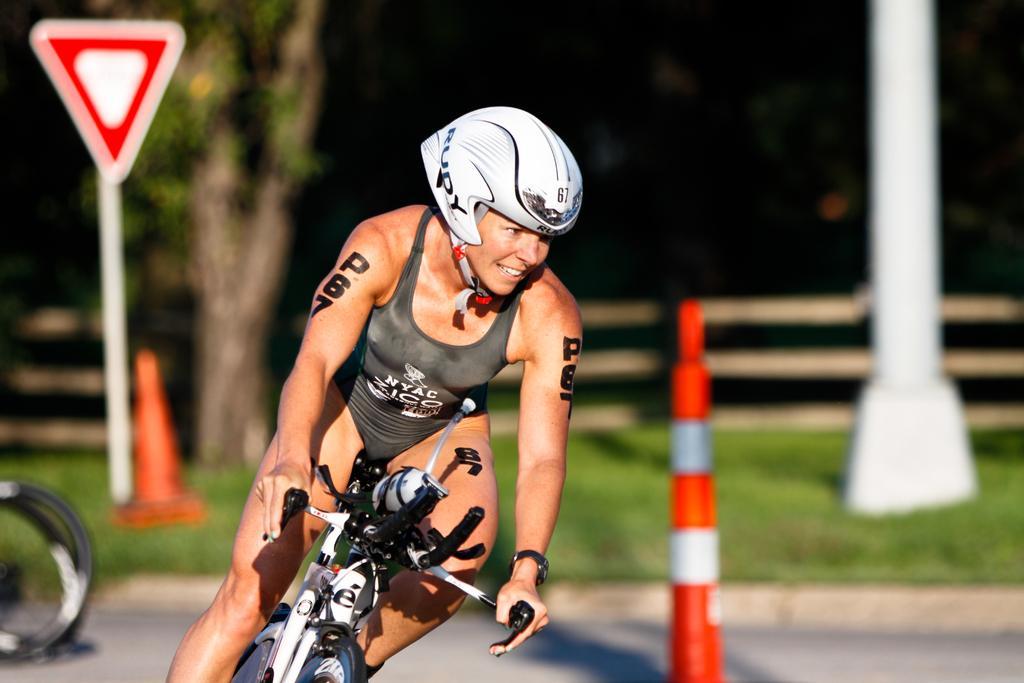Could you give a brief overview of what you see in this image? In this image I can see a woman is sitting on a bicycle in the front. I can see she is wearing a white colour helmet, grey colour dress and a black colour watch. I can also see something is written on her arms. In the background I can see traffic cones, grass, a pole, a sign board, a tree and I can see this image is little bit blurry in the background. 